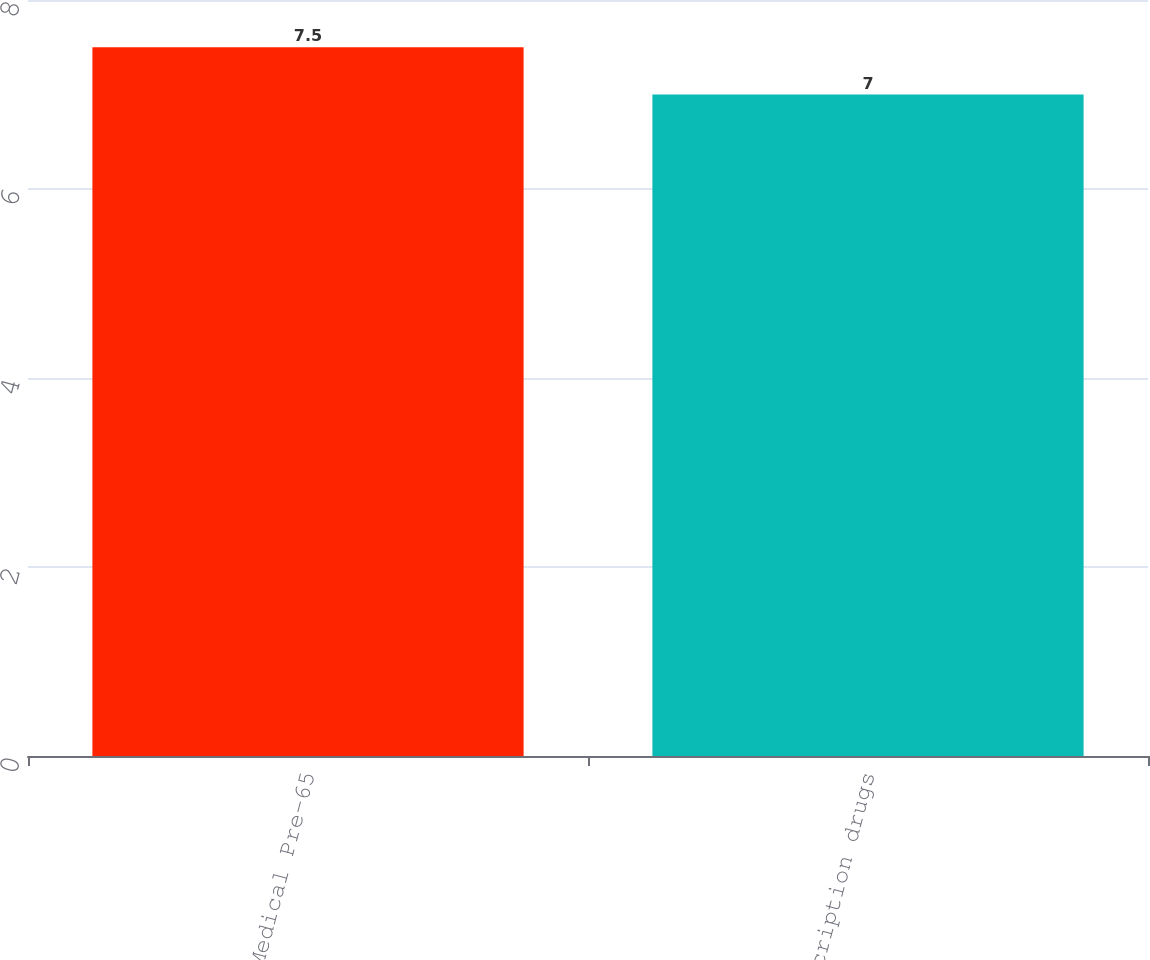<chart> <loc_0><loc_0><loc_500><loc_500><bar_chart><fcel>Medical Pre-65<fcel>Prescription drugs<nl><fcel>7.5<fcel>7<nl></chart> 